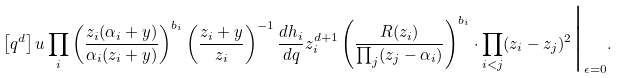Convert formula to latex. <formula><loc_0><loc_0><loc_500><loc_500>\left [ q ^ { d } \right ] u \prod _ { i } \left ( \frac { z _ { i } ( \alpha _ { i } + y ) } { \alpha _ { i } ( z _ { i } + y ) } \right ) ^ { b _ { i } } \left ( \frac { z _ { i } + y } { z _ { i } } \right ) ^ { - 1 } \frac { d h _ { i } } { d q } z _ { i } ^ { d + 1 } \left ( \frac { R ( z _ { i } ) } { \prod _ { j } ( z _ { j } - \alpha _ { i } ) } \right ) ^ { b _ { i } } \cdot \prod _ { i < j } ( z _ { i } - z _ { j } ) ^ { 2 } \Big { | } _ { \epsilon = 0 } .</formula> 